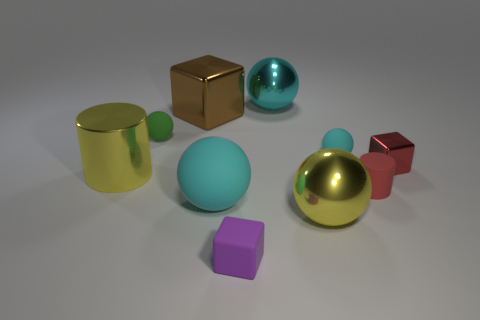Subtract all tiny balls. How many balls are left? 3 Subtract 1 blocks. How many blocks are left? 2 Subtract all red cylinders. How many cyan balls are left? 3 Add 5 green matte balls. How many green matte balls exist? 6 Subtract all red cylinders. How many cylinders are left? 1 Subtract 1 yellow cylinders. How many objects are left? 9 Subtract all cylinders. How many objects are left? 8 Subtract all purple cylinders. Subtract all blue balls. How many cylinders are left? 2 Subtract all tiny yellow rubber spheres. Subtract all yellow cylinders. How many objects are left? 9 Add 3 tiny rubber cylinders. How many tiny rubber cylinders are left? 4 